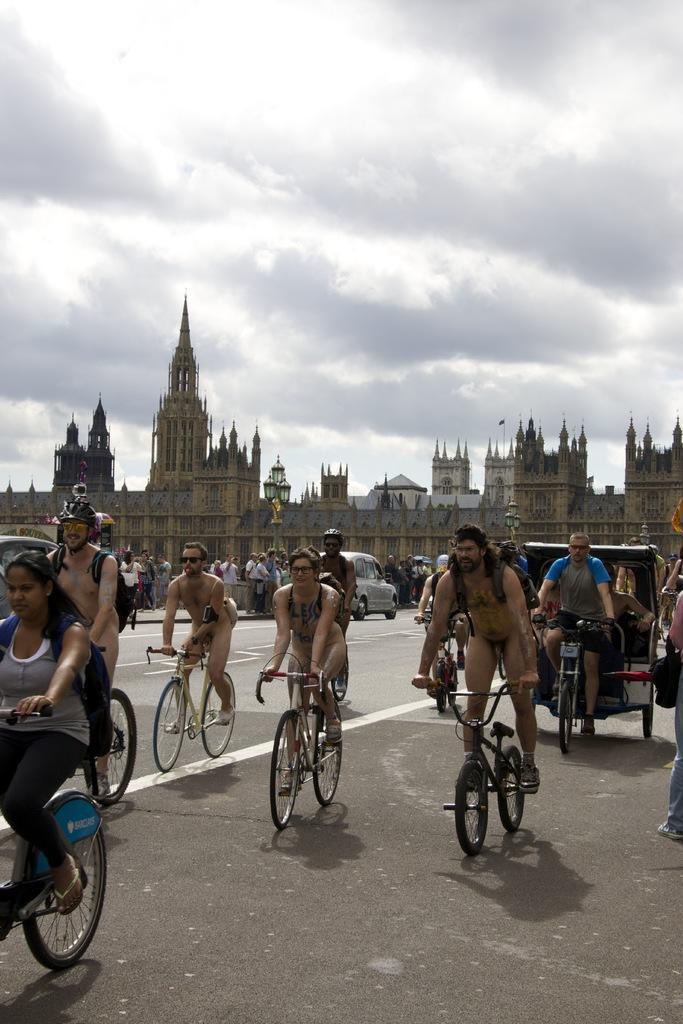Could you give a brief overview of what you see in this image? In this image, some peoples are riding bicycles. We can see few vehicles. Background ,there is a building. Few peoples are standing in the middle. We can see road and cloudy sky. 